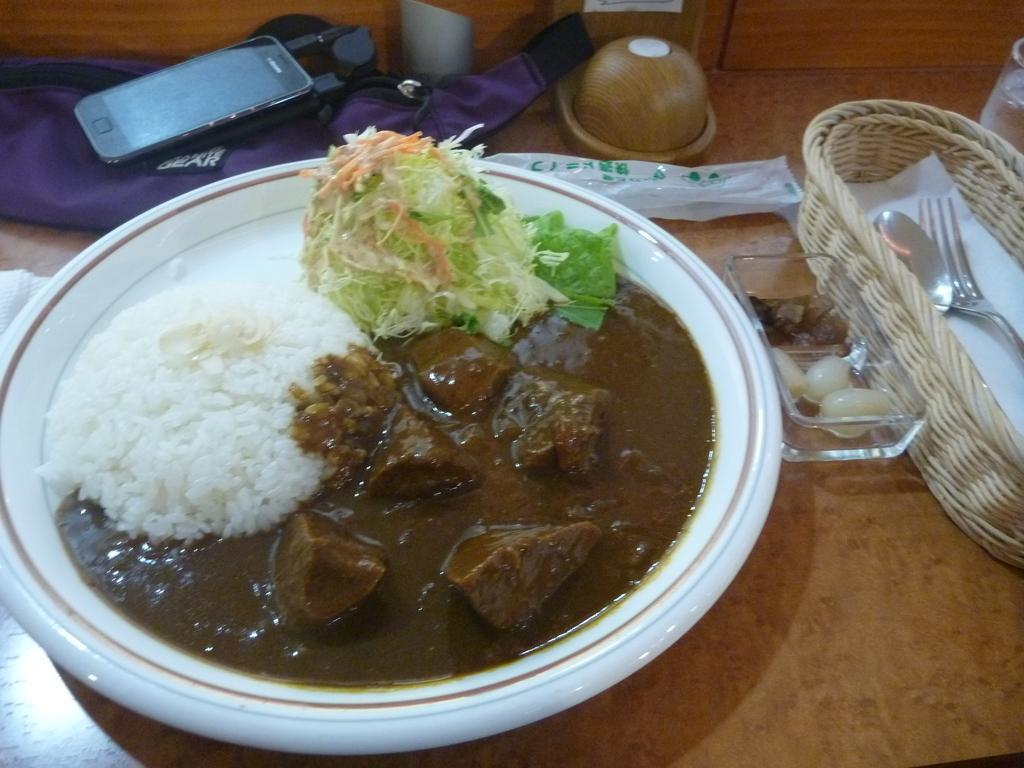Please provide a concise description of this image. In this image there are food items on a plate. Beside the plate there are a few other objects on the table. 